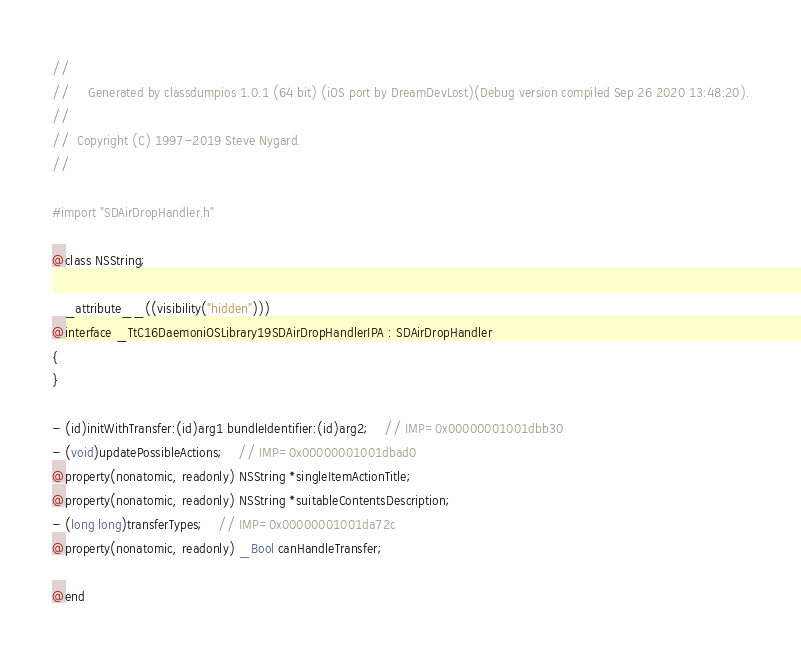Convert code to text. <code><loc_0><loc_0><loc_500><loc_500><_C_>//
//     Generated by classdumpios 1.0.1 (64 bit) (iOS port by DreamDevLost)(Debug version compiled Sep 26 2020 13:48:20).
//
//  Copyright (C) 1997-2019 Steve Nygard.
//

#import "SDAirDropHandler.h"

@class NSString;

__attribute__((visibility("hidden")))
@interface _TtC16DaemoniOSLibrary19SDAirDropHandlerIPA : SDAirDropHandler
{
}

- (id)initWithTransfer:(id)arg1 bundleIdentifier:(id)arg2;	// IMP=0x00000001001dbb30
- (void)updatePossibleActions;	// IMP=0x00000001001dbad0
@property(nonatomic, readonly) NSString *singleItemActionTitle;
@property(nonatomic, readonly) NSString *suitableContentsDescription;
- (long long)transferTypes;	// IMP=0x00000001001da72c
@property(nonatomic, readonly) _Bool canHandleTransfer;

@end

</code> 